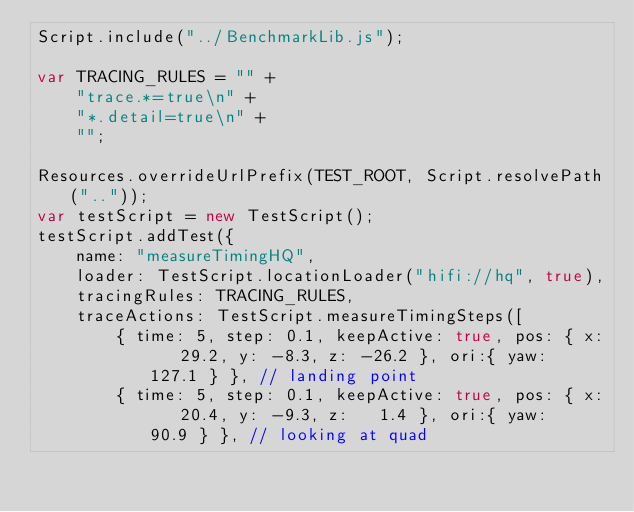Convert code to text. <code><loc_0><loc_0><loc_500><loc_500><_JavaScript_>Script.include("../BenchmarkLib.js");

var TRACING_RULES = "" +
    "trace.*=true\n" +
    "*.detail=true\n" +
    "";

Resources.overrideUrlPrefix(TEST_ROOT, Script.resolvePath(".."));
var testScript = new TestScript();
testScript.addTest({
    name: "measureTimingHQ",
    loader: TestScript.locationLoader("hifi://hq", true),
    tracingRules: TRACING_RULES,
    traceActions: TestScript.measureTimingSteps([
        { time: 5, step: 0.1, keepActive: true, pos: { x:   29.2, y: -8.3, z: -26.2 }, ori:{ yaw:  127.1 } }, // landing point
        { time: 5, step: 0.1, keepActive: true, pos: { x:   20.4, y: -9.3, z:   1.4 }, ori:{ yaw:   90.9 } }, // looking at quad</code> 